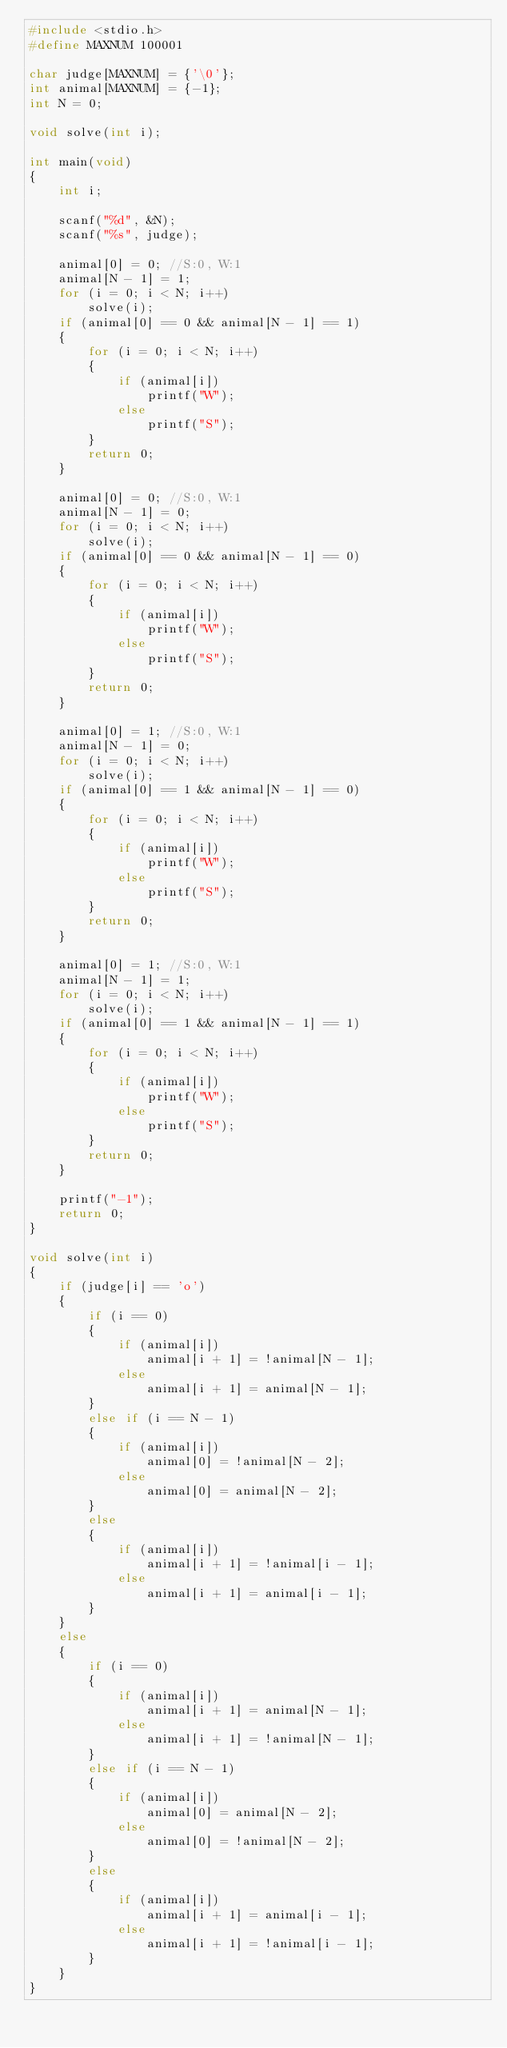Convert code to text. <code><loc_0><loc_0><loc_500><loc_500><_C_>#include <stdio.h>
#define MAXNUM 100001

char judge[MAXNUM] = {'\0'};
int animal[MAXNUM] = {-1};
int N = 0;

void solve(int i);

int main(void)
{
    int i;

    scanf("%d", &N);
    scanf("%s", judge);

    animal[0] = 0; //S:0, W:1
    animal[N - 1] = 1;
    for (i = 0; i < N; i++)
        solve(i);
    if (animal[0] == 0 && animal[N - 1] == 1)
    {
        for (i = 0; i < N; i++)
        {
            if (animal[i])
                printf("W");
            else
                printf("S");
        }
        return 0;
    }

    animal[0] = 0; //S:0, W:1
    animal[N - 1] = 0;
    for (i = 0; i < N; i++)
        solve(i);
    if (animal[0] == 0 && animal[N - 1] == 0)
    {
        for (i = 0; i < N; i++)
        {
            if (animal[i])
                printf("W");
            else
                printf("S");
        }
        return 0;
    }

    animal[0] = 1; //S:0, W:1
    animal[N - 1] = 0;
    for (i = 0; i < N; i++)
        solve(i);
    if (animal[0] == 1 && animal[N - 1] == 0)
    {
        for (i = 0; i < N; i++)
        {
            if (animal[i])
                printf("W");
            else
                printf("S");
        }
        return 0;
    }

    animal[0] = 1; //S:0, W:1
    animal[N - 1] = 1;
    for (i = 0; i < N; i++)
        solve(i);
    if (animal[0] == 1 && animal[N - 1] == 1)
    {
        for (i = 0; i < N; i++)
        {
            if (animal[i])
                printf("W");
            else
                printf("S");
        }
        return 0;
    }

    printf("-1");
    return 0;
}

void solve(int i)
{
    if (judge[i] == 'o')
    {
        if (i == 0)
        {
            if (animal[i])
                animal[i + 1] = !animal[N - 1];
            else
                animal[i + 1] = animal[N - 1];
        }
        else if (i == N - 1)
        {
            if (animal[i])
                animal[0] = !animal[N - 2];
            else
                animal[0] = animal[N - 2];
        }
        else
        {
            if (animal[i])
                animal[i + 1] = !animal[i - 1];
            else
                animal[i + 1] = animal[i - 1];
        }
    }
    else
    {
        if (i == 0)
        {
            if (animal[i])
                animal[i + 1] = animal[N - 1];
            else
                animal[i + 1] = !animal[N - 1];
        }
        else if (i == N - 1)
        {
            if (animal[i])
                animal[0] = animal[N - 2];
            else
                animal[0] = !animal[N - 2];
        }
        else
        {
            if (animal[i])
                animal[i + 1] = animal[i - 1];
            else
                animal[i + 1] = !animal[i - 1];
        }
    }
}</code> 